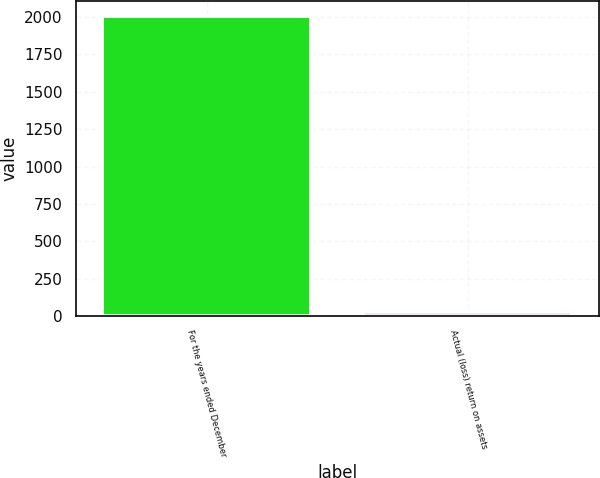Convert chart. <chart><loc_0><loc_0><loc_500><loc_500><bar_chart><fcel>For the years ended December<fcel>Actual (loss) return on assets<nl><fcel>2008<fcel>24.1<nl></chart> 